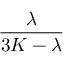<formula> <loc_0><loc_0><loc_500><loc_500>\frac { \lambda } { 3 K - \lambda }</formula> 